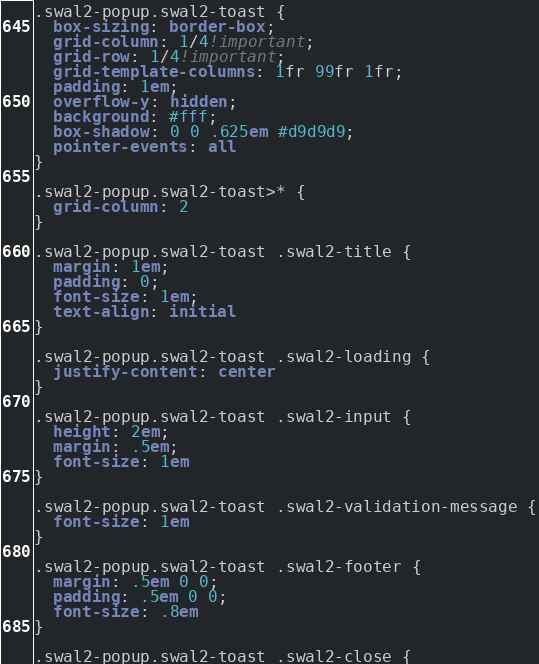Convert code to text. <code><loc_0><loc_0><loc_500><loc_500><_CSS_>.swal2-popup.swal2-toast {
  box-sizing: border-box;
  grid-column: 1/4!important;
  grid-row: 1/4!important;
  grid-template-columns: 1fr 99fr 1fr;
  padding: 1em;
  overflow-y: hidden;
  background: #fff;
  box-shadow: 0 0 .625em #d9d9d9;
  pointer-events: all
}

.swal2-popup.swal2-toast>* {
  grid-column: 2
}

.swal2-popup.swal2-toast .swal2-title {
  margin: 1em;
  padding: 0;
  font-size: 1em;
  text-align: initial
}

.swal2-popup.swal2-toast .swal2-loading {
  justify-content: center
}

.swal2-popup.swal2-toast .swal2-input {
  height: 2em;
  margin: .5em;
  font-size: 1em
}

.swal2-popup.swal2-toast .swal2-validation-message {
  font-size: 1em
}

.swal2-popup.swal2-toast .swal2-footer {
  margin: .5em 0 0;
  padding: .5em 0 0;
  font-size: .8em
}

.swal2-popup.swal2-toast .swal2-close {</code> 